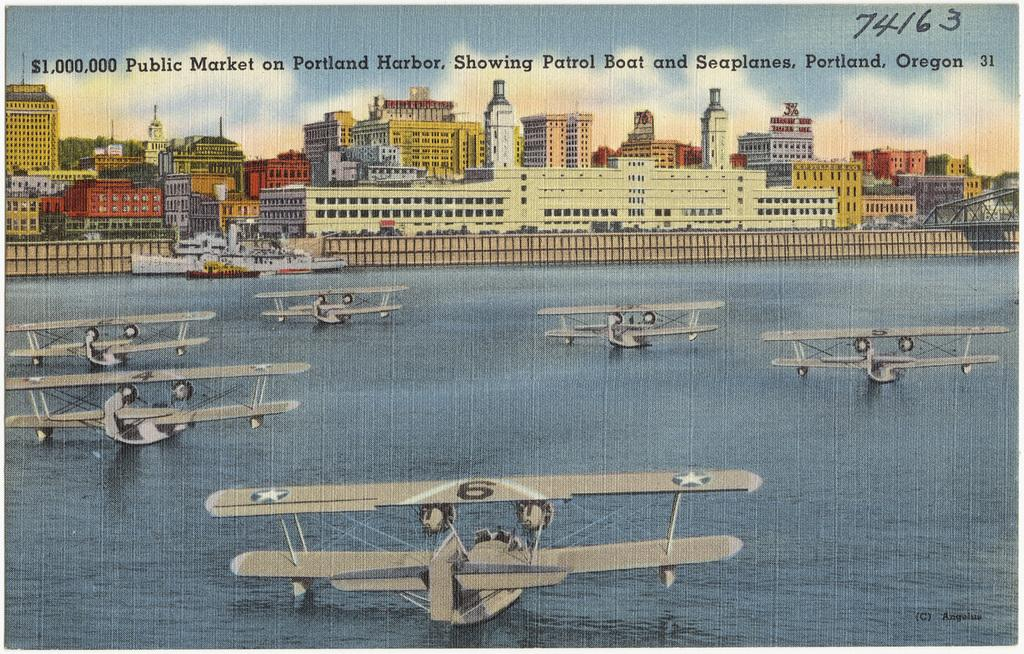What is featured on the poster in the image? The poster contains a boat and chopper-like boats. What other structures are visible in the image? There are buildings and houses visible in the image. What type of sweater is the fairy wearing in the image? There are no fairies or sweaters present in the image. 